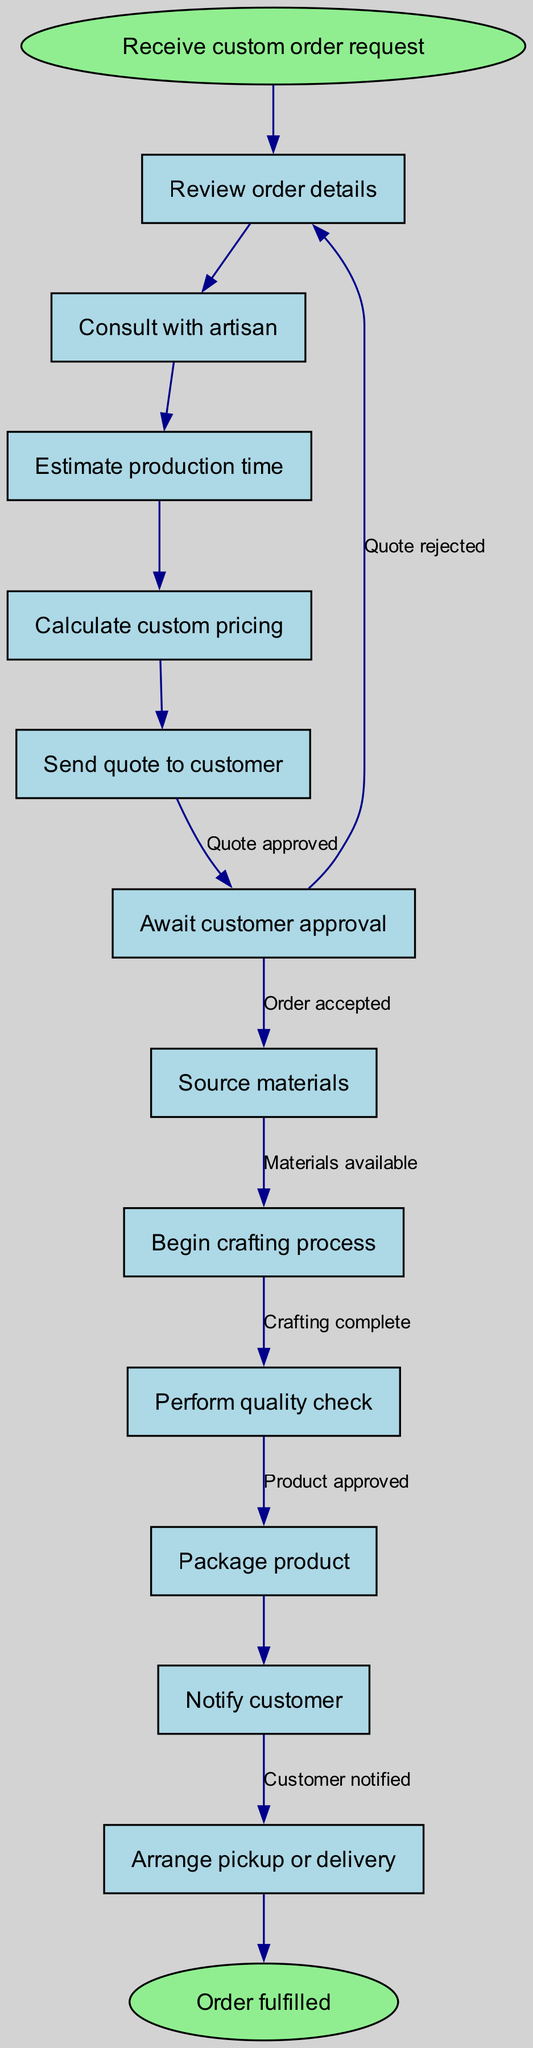What is the starting point of the workflow? The starting point of the workflow is indicated by the 'start' node, which states "Receive custom order request." This is the initial action that triggers the entire order fulfillment process.
Answer: Receive custom order request How many nodes are present in the workflow? The diagram includes multiple nodes that represent the steps in the workflow. Counting each individual step listed under the "nodes" section, we find there are a total of 12 nodes, including the start and end nodes.
Answer: 12 What follows after “Send quote to customer”? In the order fulfillment workflow, after the action "Send quote to customer," the next step is "Await customer approval." This links the two actions together in a sequential manner.
Answer: Await customer approval Which step involves checking the quality of the product? The step that involves checking the quality of the product is "Perform quality check." This step is specifically designated for ensuring that the crafted product meets the necessary standards before packaging.
Answer: Perform quality check What are the possible outcomes after "Await customer approval"? After "Await customer approval," there are two possible outcomes: "Source materials" if the quote is approved, or it can return to "Send quote to customer" if the quote is rejected. This delineates the decision that needs to be made by the customer after receiving the quote.
Answer: Quote approved, Quote rejected What is the final step recorded in the workflow? The final step recorded in the workflow is indicated by the 'end' node, which states "Order fulfilled." This signifies the completion of the process after all steps have been successfully executed.
Answer: Order fulfilled How does the process transition from “Begin crafting process” to the next step? The transition from "Begin crafting process" to the next step, "Perform quality check," occurs once crafting is completed. The diagram establishes a direct relationship where the crafting must be fully accomplished before the quality check can take place.
Answer: Crafting complete What action takes place immediately after "Estimate production time"? Immediately following "Estimate production time," the next action in the workflow is "Calculate custom pricing." Each step is connected in logical order, laying out the sequence in which tasks must be completed.
Answer: Calculate custom pricing 